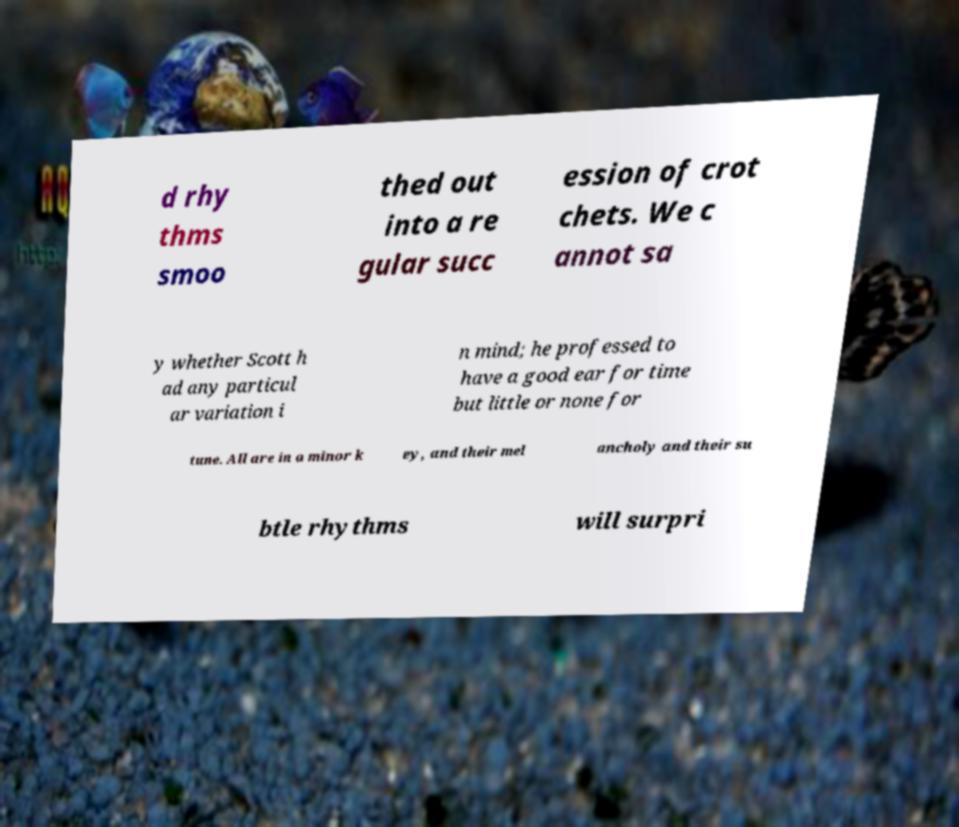Can you accurately transcribe the text from the provided image for me? d rhy thms smoo thed out into a re gular succ ession of crot chets. We c annot sa y whether Scott h ad any particul ar variation i n mind; he professed to have a good ear for time but little or none for tune. All are in a minor k ey, and their mel ancholy and their su btle rhythms will surpri 